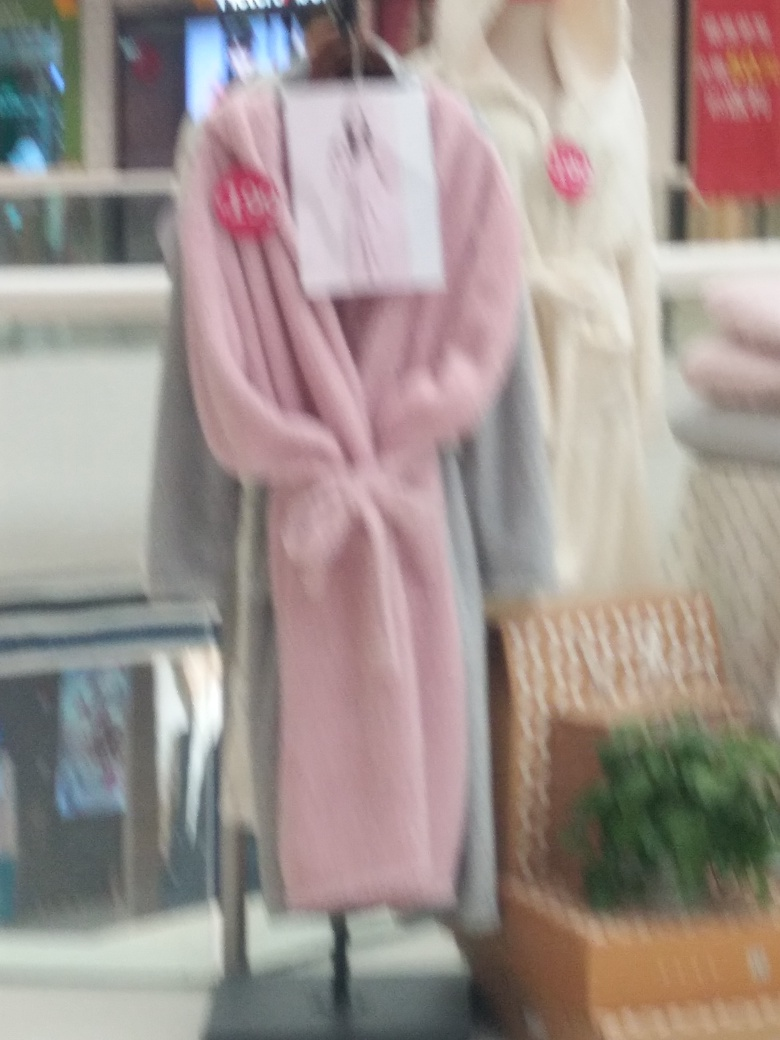What kind of setting does this image seem to depict? The setting of the image seems to be a retail or shopping environment, suggested by the clothing items placed on mannequins and the commercial surroundings, possibly within a store or mall. 